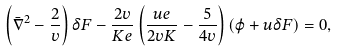Convert formula to latex. <formula><loc_0><loc_0><loc_500><loc_500>\left ( \bar { \nabla } ^ { 2 } - \frac { 2 } { v } \right ) \delta F - \frac { 2 v } { K e } \left ( \frac { u e } { 2 v K } - \frac { 5 } { 4 v } \right ) \left ( \varphi + u \delta F \right ) = 0 ,</formula> 